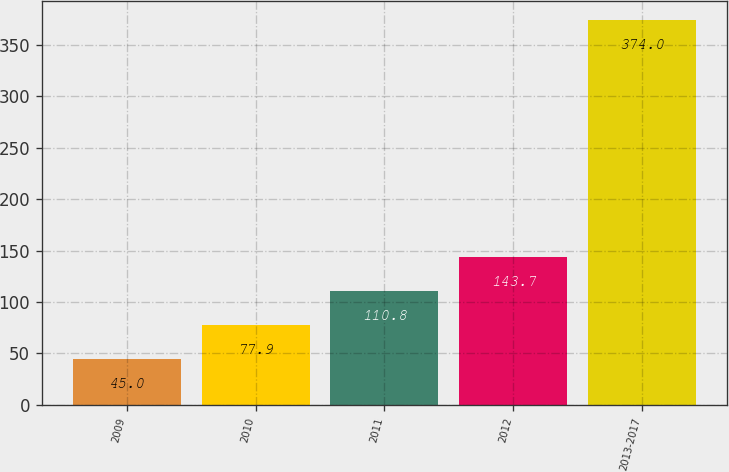Convert chart. <chart><loc_0><loc_0><loc_500><loc_500><bar_chart><fcel>2009<fcel>2010<fcel>2011<fcel>2012<fcel>2013-2017<nl><fcel>45<fcel>77.9<fcel>110.8<fcel>143.7<fcel>374<nl></chart> 